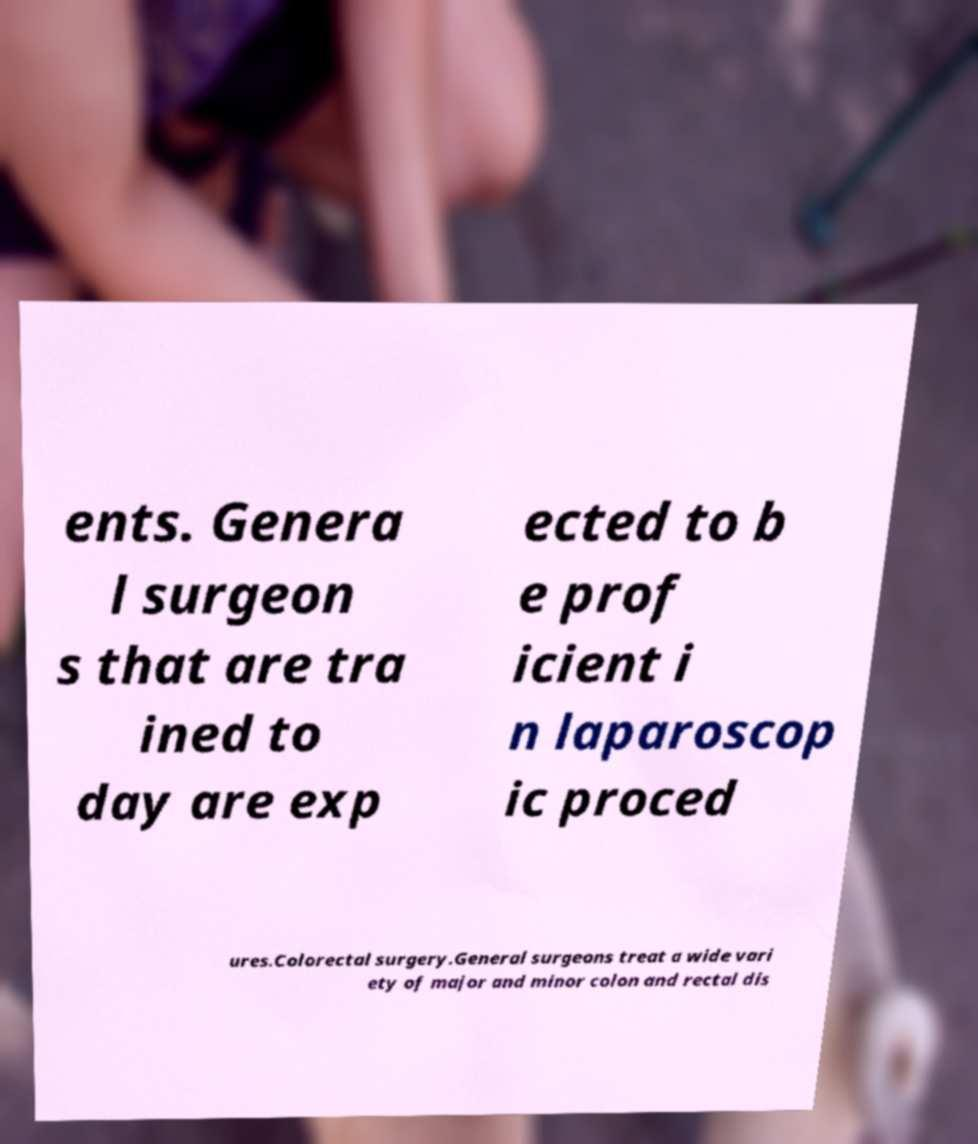Can you read and provide the text displayed in the image?This photo seems to have some interesting text. Can you extract and type it out for me? ents. Genera l surgeon s that are tra ined to day are exp ected to b e prof icient i n laparoscop ic proced ures.Colorectal surgery.General surgeons treat a wide vari ety of major and minor colon and rectal dis 